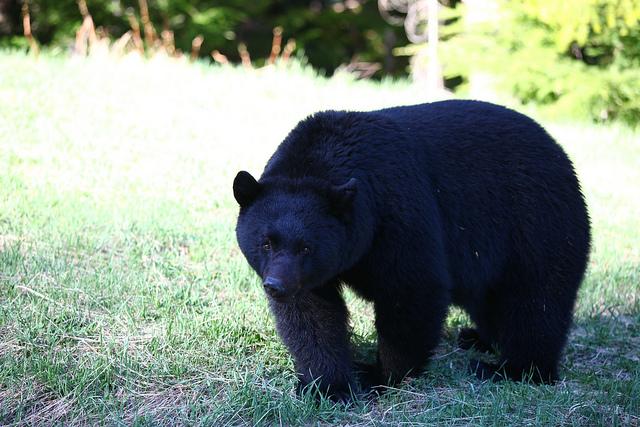What kind of bear is this?
Answer briefly. Black. What animal is the scene?
Answer briefly. Bear. How many legs does this animal have?
Write a very short answer. 4. Is the bear brown?
Be succinct. No. Is the cameraman too close?
Concise answer only. Yes. What is all over the ground?
Write a very short answer. Grass. Is it a black, brown or polar bear?
Short answer required. Black. How many bears are there?
Give a very brief answer. 1. What color is the bear?
Answer briefly. Black. 